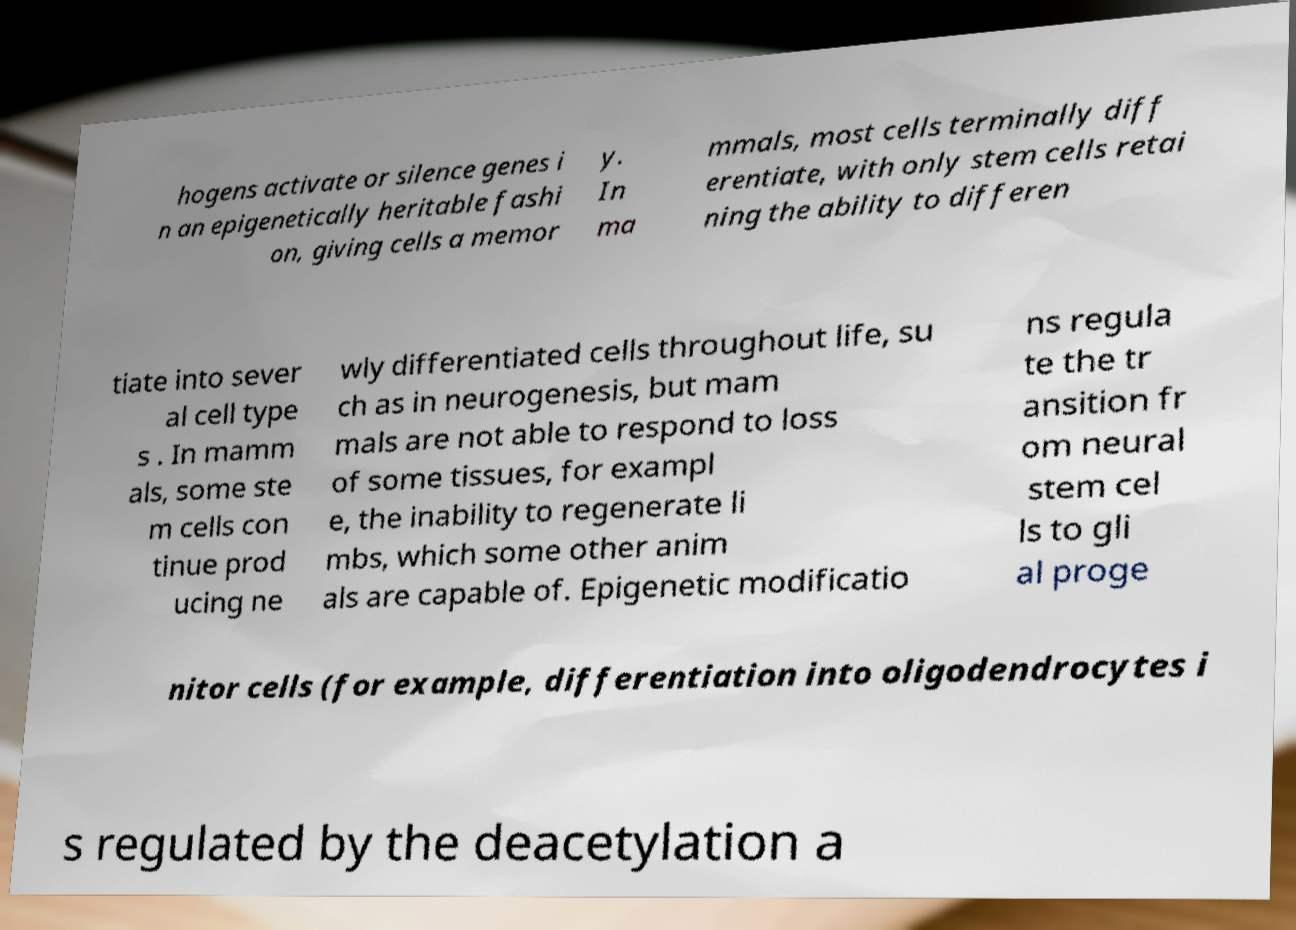I need the written content from this picture converted into text. Can you do that? hogens activate or silence genes i n an epigenetically heritable fashi on, giving cells a memor y. In ma mmals, most cells terminally diff erentiate, with only stem cells retai ning the ability to differen tiate into sever al cell type s . In mamm als, some ste m cells con tinue prod ucing ne wly differentiated cells throughout life, su ch as in neurogenesis, but mam mals are not able to respond to loss of some tissues, for exampl e, the inability to regenerate li mbs, which some other anim als are capable of. Epigenetic modificatio ns regula te the tr ansition fr om neural stem cel ls to gli al proge nitor cells (for example, differentiation into oligodendrocytes i s regulated by the deacetylation a 